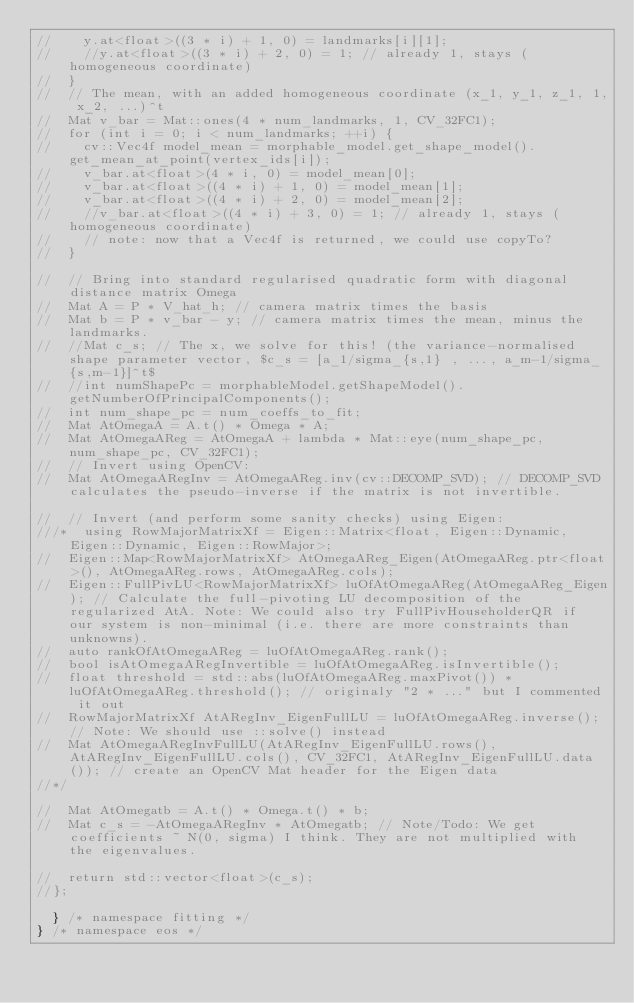<code> <loc_0><loc_0><loc_500><loc_500><_C++_>//		y.at<float>((3 * i) + 1, 0) = landmarks[i][1];
//		//y.at<float>((3 * i) + 2, 0) = 1; // already 1, stays (homogeneous coordinate)
//	}
//	// The mean, with an added homogeneous coordinate (x_1, y_1, z_1, 1, x_2, ...)^t
//	Mat v_bar = Mat::ones(4 * num_landmarks, 1, CV_32FC1);
//	for (int i = 0; i < num_landmarks; ++i) {
//		cv::Vec4f model_mean = morphable_model.get_shape_model().get_mean_at_point(vertex_ids[i]);
//		v_bar.at<float>(4 * i, 0) = model_mean[0];
//		v_bar.at<float>((4 * i) + 1, 0) = model_mean[1];
//		v_bar.at<float>((4 * i) + 2, 0) = model_mean[2];
//		//v_bar.at<float>((4 * i) + 3, 0) = 1; // already 1, stays (homogeneous coordinate)
//		// note: now that a Vec4f is returned, we could use copyTo?
//	}

//	// Bring into standard regularised quadratic form with diagonal distance matrix Omega
//	Mat A = P * V_hat_h; // camera matrix times the basis
//	Mat b = P * v_bar - y; // camera matrix times the mean, minus the landmarks.
//	//Mat c_s; // The x, we solve for this! (the variance-normalised shape parameter vector, $c_s = [a_1/sigma_{s,1} , ..., a_m-1/sigma_{s,m-1}]^t$
//	//int numShapePc = morphableModel.getShapeModel().getNumberOfPrincipalComponents();
//	int num_shape_pc = num_coeffs_to_fit;
//	Mat AtOmegaA = A.t() * Omega * A;
//	Mat AtOmegaAReg = AtOmegaA + lambda * Mat::eye(num_shape_pc, num_shape_pc, CV_32FC1);
//	// Invert using OpenCV:
//	Mat AtOmegaARegInv = AtOmegaAReg.inv(cv::DECOMP_SVD); // DECOMP_SVD calculates the pseudo-inverse if the matrix is not invertible.

//	// Invert (and perform some sanity checks) using Eigen:
///*	using RowMajorMatrixXf = Eigen::Matrix<float, Eigen::Dynamic, Eigen::Dynamic, Eigen::RowMajor>;
//	Eigen::Map<RowMajorMatrixXf> AtOmegaAReg_Eigen(AtOmegaAReg.ptr<float>(), AtOmegaAReg.rows, AtOmegaAReg.cols);
//	Eigen::FullPivLU<RowMajorMatrixXf> luOfAtOmegaAReg(AtOmegaAReg_Eigen); // Calculate the full-pivoting LU decomposition of the regularized AtA. Note: We could also try FullPivHouseholderQR if our system is non-minimal (i.e. there are more constraints than unknowns).
//	auto rankOfAtOmegaAReg = luOfAtOmegaAReg.rank();
//	bool isAtOmegaARegInvertible = luOfAtOmegaAReg.isInvertible();
//	float threshold = std::abs(luOfAtOmegaAReg.maxPivot()) * luOfAtOmegaAReg.threshold(); // originaly "2 * ..." but I commented it out
//	RowMajorMatrixXf AtARegInv_EigenFullLU = luOfAtOmegaAReg.inverse(); // Note: We should use ::solve() instead
//	Mat AtOmegaARegInvFullLU(AtARegInv_EigenFullLU.rows(), AtARegInv_EigenFullLU.cols(), CV_32FC1, AtARegInv_EigenFullLU.data()); // create an OpenCV Mat header for the Eigen data
//*/

//	Mat AtOmegatb = A.t() * Omega.t() * b;
//	Mat c_s = -AtOmegaARegInv * AtOmegatb; // Note/Todo: We get coefficients ~ N(0, sigma) I think. They are not multiplied with the eigenvalues.

//	return std::vector<float>(c_s);
//};

	} /* namespace fitting */
} /* namespace eos */

</code> 